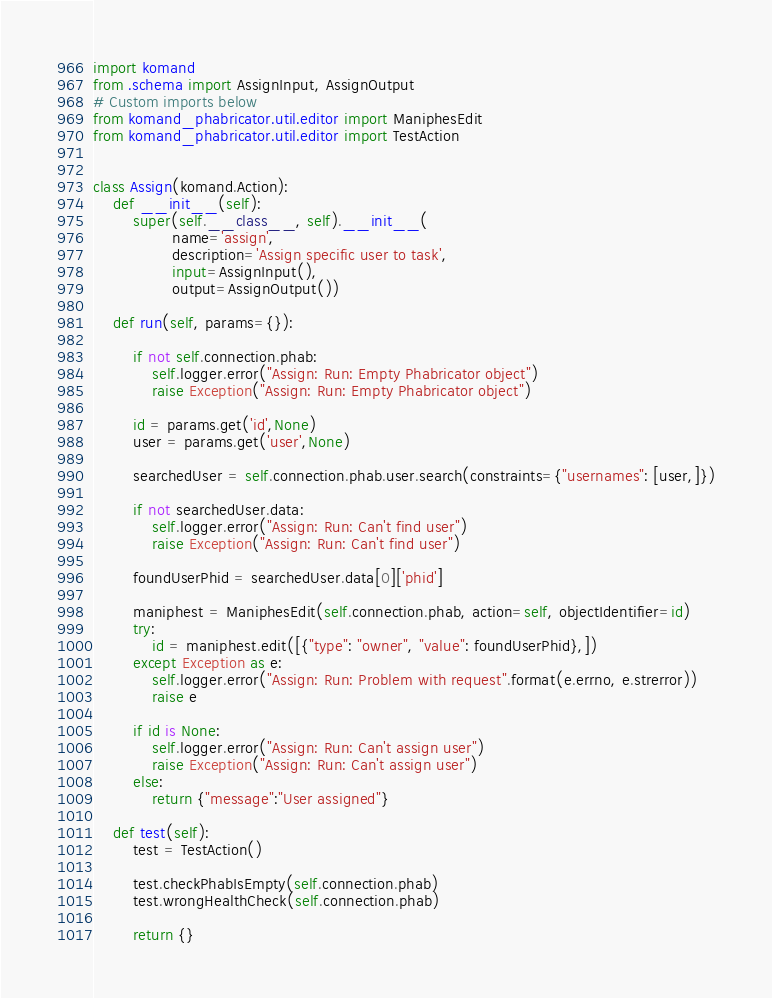<code> <loc_0><loc_0><loc_500><loc_500><_Python_>import komand
from .schema import AssignInput, AssignOutput
# Custom imports below
from komand_phabricator.util.editor import ManiphesEdit
from komand_phabricator.util.editor import TestAction


class Assign(komand.Action):
    def __init__(self):
        super(self.__class__, self).__init__(
                name='assign',
                description='Assign specific user to task',
                input=AssignInput(),
                output=AssignOutput())

    def run(self, params={}):

        if not self.connection.phab:
            self.logger.error("Assign: Run: Empty Phabricator object")
            raise Exception("Assign: Run: Empty Phabricator object")

        id = params.get('id',None)
        user = params.get('user',None)

        searchedUser = self.connection.phab.user.search(constraints={"usernames": [user,]})

        if not searchedUser.data:
            self.logger.error("Assign: Run: Can't find user")
            raise Exception("Assign: Run: Can't find user")

        foundUserPhid = searchedUser.data[0]['phid']

        maniphest = ManiphesEdit(self.connection.phab, action=self, objectIdentifier=id)
        try:
            id = maniphest.edit([{"type": "owner", "value": foundUserPhid},])
        except Exception as e:
            self.logger.error("Assign: Run: Problem with request".format(e.errno, e.strerror))
            raise e

        if id is None:
            self.logger.error("Assign: Run: Can't assign user")
            raise Exception("Assign: Run: Can't assign user")
        else:
            return {"message":"User assigned"}

    def test(self):
        test = TestAction()

        test.checkPhabIsEmpty(self.connection.phab)
        test.wrongHealthCheck(self.connection.phab)

        return {}
</code> 